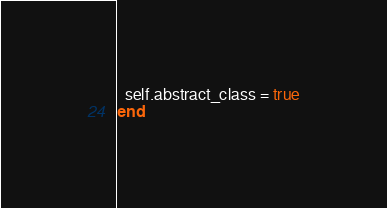Convert code to text. <code><loc_0><loc_0><loc_500><loc_500><_Ruby_>  self.abstract_class = true
end
</code> 